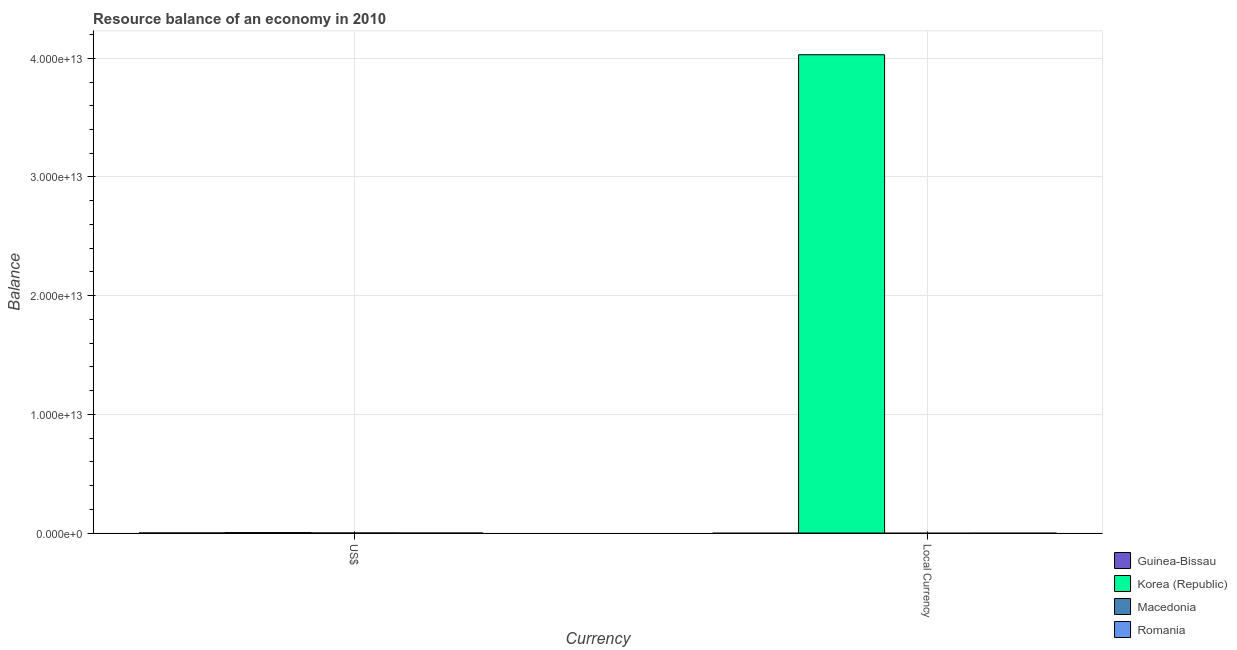Are the number of bars per tick equal to the number of legend labels?
Keep it short and to the point. No. Are the number of bars on each tick of the X-axis equal?
Keep it short and to the point. Yes. How many bars are there on the 2nd tick from the left?
Provide a short and direct response. 1. What is the label of the 2nd group of bars from the left?
Ensure brevity in your answer.  Local Currency. Across all countries, what is the maximum resource balance in constant us$?
Provide a succinct answer. 4.03e+13. Across all countries, what is the minimum resource balance in us$?
Offer a very short reply. 0. What is the total resource balance in constant us$ in the graph?
Make the answer very short. 4.03e+13. What is the difference between the resource balance in us$ in Macedonia and the resource balance in constant us$ in Romania?
Ensure brevity in your answer.  0. What is the average resource balance in constant us$ per country?
Your response must be concise. 1.01e+13. What is the difference between the resource balance in constant us$ and resource balance in us$ in Korea (Republic)?
Your answer should be very brief. 4.03e+13. In how many countries, is the resource balance in constant us$ greater than 38000000000000 units?
Your answer should be compact. 1. What is the difference between two consecutive major ticks on the Y-axis?
Provide a short and direct response. 1.00e+13. Does the graph contain any zero values?
Provide a succinct answer. Yes. Does the graph contain grids?
Make the answer very short. Yes. How are the legend labels stacked?
Your response must be concise. Vertical. What is the title of the graph?
Keep it short and to the point. Resource balance of an economy in 2010. What is the label or title of the X-axis?
Make the answer very short. Currency. What is the label or title of the Y-axis?
Keep it short and to the point. Balance. What is the Balance in Korea (Republic) in US$?
Offer a terse response. 3.49e+1. What is the Balance of Macedonia in US$?
Keep it short and to the point. 0. What is the Balance in Romania in US$?
Your answer should be compact. 0. What is the Balance of Guinea-Bissau in Local Currency?
Give a very brief answer. 0. What is the Balance of Korea (Republic) in Local Currency?
Offer a very short reply. 4.03e+13. Across all Currency, what is the maximum Balance in Korea (Republic)?
Your response must be concise. 4.03e+13. Across all Currency, what is the minimum Balance of Korea (Republic)?
Keep it short and to the point. 3.49e+1. What is the total Balance of Korea (Republic) in the graph?
Provide a succinct answer. 4.03e+13. What is the total Balance of Romania in the graph?
Make the answer very short. 0. What is the difference between the Balance in Korea (Republic) in US$ and that in Local Currency?
Your answer should be very brief. -4.03e+13. What is the average Balance of Korea (Republic) per Currency?
Your answer should be very brief. 2.02e+13. What is the ratio of the Balance of Korea (Republic) in US$ to that in Local Currency?
Give a very brief answer. 0. What is the difference between the highest and the second highest Balance of Korea (Republic)?
Your answer should be compact. 4.03e+13. What is the difference between the highest and the lowest Balance in Korea (Republic)?
Make the answer very short. 4.03e+13. 